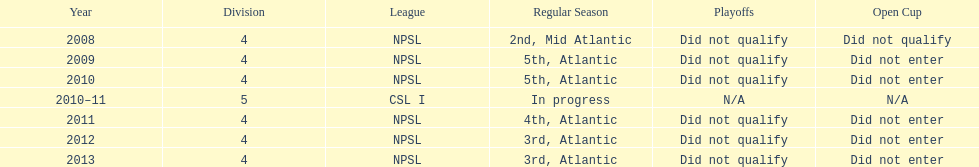Using the data, what should be the next year they will play? 2014. 